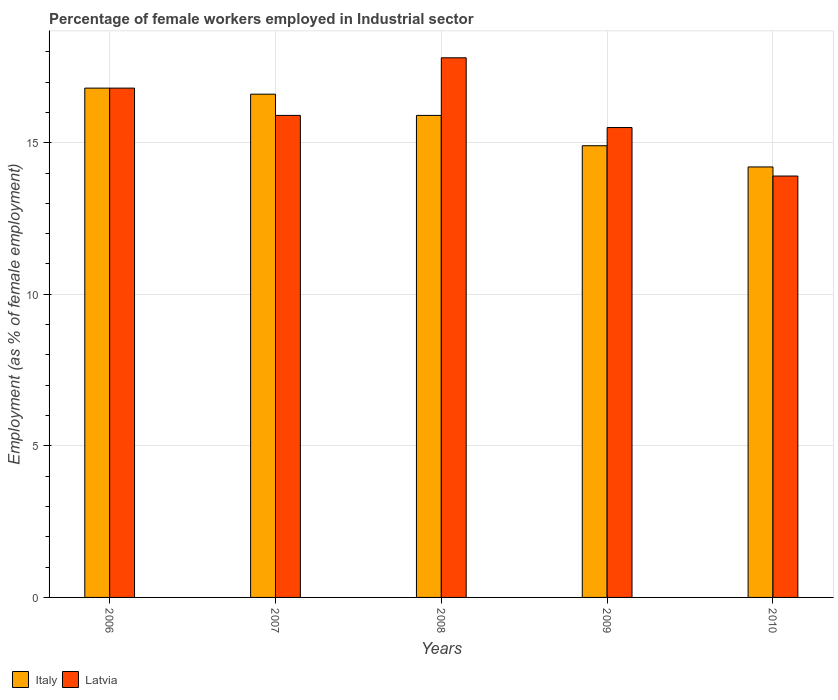How many bars are there on the 3rd tick from the left?
Offer a terse response. 2. What is the label of the 3rd group of bars from the left?
Provide a short and direct response. 2008. In how many cases, is the number of bars for a given year not equal to the number of legend labels?
Provide a short and direct response. 0. What is the percentage of females employed in Industrial sector in Latvia in 2008?
Your response must be concise. 17.8. Across all years, what is the maximum percentage of females employed in Industrial sector in Latvia?
Your response must be concise. 17.8. Across all years, what is the minimum percentage of females employed in Industrial sector in Latvia?
Your answer should be very brief. 13.9. What is the total percentage of females employed in Industrial sector in Latvia in the graph?
Your answer should be compact. 79.9. What is the difference between the percentage of females employed in Industrial sector in Italy in 2006 and that in 2009?
Your response must be concise. 1.9. What is the difference between the percentage of females employed in Industrial sector in Latvia in 2007 and the percentage of females employed in Industrial sector in Italy in 2010?
Keep it short and to the point. 1.7. What is the average percentage of females employed in Industrial sector in Latvia per year?
Offer a very short reply. 15.98. In the year 2009, what is the difference between the percentage of females employed in Industrial sector in Italy and percentage of females employed in Industrial sector in Latvia?
Your answer should be very brief. -0.6. In how many years, is the percentage of females employed in Industrial sector in Italy greater than 4 %?
Your response must be concise. 5. What is the ratio of the percentage of females employed in Industrial sector in Italy in 2006 to that in 2009?
Your response must be concise. 1.13. What is the difference between the highest and the second highest percentage of females employed in Industrial sector in Latvia?
Offer a terse response. 1. What is the difference between the highest and the lowest percentage of females employed in Industrial sector in Italy?
Give a very brief answer. 2.6. Is the sum of the percentage of females employed in Industrial sector in Latvia in 2007 and 2009 greater than the maximum percentage of females employed in Industrial sector in Italy across all years?
Your response must be concise. Yes. How many years are there in the graph?
Give a very brief answer. 5. Does the graph contain grids?
Keep it short and to the point. Yes. Where does the legend appear in the graph?
Your response must be concise. Bottom left. How many legend labels are there?
Make the answer very short. 2. What is the title of the graph?
Keep it short and to the point. Percentage of female workers employed in Industrial sector. Does "Papua New Guinea" appear as one of the legend labels in the graph?
Give a very brief answer. No. What is the label or title of the X-axis?
Offer a terse response. Years. What is the label or title of the Y-axis?
Your response must be concise. Employment (as % of female employment). What is the Employment (as % of female employment) in Italy in 2006?
Give a very brief answer. 16.8. What is the Employment (as % of female employment) in Latvia in 2006?
Give a very brief answer. 16.8. What is the Employment (as % of female employment) in Italy in 2007?
Offer a terse response. 16.6. What is the Employment (as % of female employment) in Latvia in 2007?
Offer a terse response. 15.9. What is the Employment (as % of female employment) in Italy in 2008?
Give a very brief answer. 15.9. What is the Employment (as % of female employment) of Latvia in 2008?
Make the answer very short. 17.8. What is the Employment (as % of female employment) in Italy in 2009?
Make the answer very short. 14.9. What is the Employment (as % of female employment) of Latvia in 2009?
Ensure brevity in your answer.  15.5. What is the Employment (as % of female employment) in Italy in 2010?
Offer a very short reply. 14.2. What is the Employment (as % of female employment) in Latvia in 2010?
Offer a very short reply. 13.9. Across all years, what is the maximum Employment (as % of female employment) in Italy?
Provide a succinct answer. 16.8. Across all years, what is the maximum Employment (as % of female employment) of Latvia?
Your response must be concise. 17.8. Across all years, what is the minimum Employment (as % of female employment) in Italy?
Give a very brief answer. 14.2. Across all years, what is the minimum Employment (as % of female employment) in Latvia?
Your answer should be very brief. 13.9. What is the total Employment (as % of female employment) in Italy in the graph?
Provide a succinct answer. 78.4. What is the total Employment (as % of female employment) in Latvia in the graph?
Your answer should be compact. 79.9. What is the difference between the Employment (as % of female employment) of Italy in 2006 and that in 2007?
Ensure brevity in your answer.  0.2. What is the difference between the Employment (as % of female employment) in Latvia in 2006 and that in 2009?
Offer a terse response. 1.3. What is the difference between the Employment (as % of female employment) in Latvia in 2006 and that in 2010?
Your response must be concise. 2.9. What is the difference between the Employment (as % of female employment) of Italy in 2007 and that in 2008?
Offer a terse response. 0.7. What is the difference between the Employment (as % of female employment) in Latvia in 2007 and that in 2009?
Keep it short and to the point. 0.4. What is the difference between the Employment (as % of female employment) of Italy in 2007 and that in 2010?
Your answer should be very brief. 2.4. What is the difference between the Employment (as % of female employment) of Italy in 2008 and that in 2010?
Provide a succinct answer. 1.7. What is the difference between the Employment (as % of female employment) of Latvia in 2008 and that in 2010?
Your response must be concise. 3.9. What is the difference between the Employment (as % of female employment) in Italy in 2009 and that in 2010?
Your answer should be compact. 0.7. What is the difference between the Employment (as % of female employment) of Latvia in 2009 and that in 2010?
Your response must be concise. 1.6. What is the difference between the Employment (as % of female employment) of Italy in 2006 and the Employment (as % of female employment) of Latvia in 2009?
Your answer should be compact. 1.3. What is the difference between the Employment (as % of female employment) in Italy in 2007 and the Employment (as % of female employment) in Latvia in 2008?
Offer a terse response. -1.2. What is the difference between the Employment (as % of female employment) in Italy in 2007 and the Employment (as % of female employment) in Latvia in 2009?
Ensure brevity in your answer.  1.1. What is the difference between the Employment (as % of female employment) in Italy in 2008 and the Employment (as % of female employment) in Latvia in 2009?
Provide a succinct answer. 0.4. What is the difference between the Employment (as % of female employment) of Italy in 2008 and the Employment (as % of female employment) of Latvia in 2010?
Your response must be concise. 2. What is the difference between the Employment (as % of female employment) of Italy in 2009 and the Employment (as % of female employment) of Latvia in 2010?
Offer a terse response. 1. What is the average Employment (as % of female employment) of Italy per year?
Give a very brief answer. 15.68. What is the average Employment (as % of female employment) in Latvia per year?
Offer a terse response. 15.98. In the year 2006, what is the difference between the Employment (as % of female employment) in Italy and Employment (as % of female employment) in Latvia?
Ensure brevity in your answer.  0. In the year 2009, what is the difference between the Employment (as % of female employment) of Italy and Employment (as % of female employment) of Latvia?
Make the answer very short. -0.6. What is the ratio of the Employment (as % of female employment) of Italy in 2006 to that in 2007?
Your answer should be very brief. 1.01. What is the ratio of the Employment (as % of female employment) of Latvia in 2006 to that in 2007?
Your answer should be very brief. 1.06. What is the ratio of the Employment (as % of female employment) of Italy in 2006 to that in 2008?
Keep it short and to the point. 1.06. What is the ratio of the Employment (as % of female employment) of Latvia in 2006 to that in 2008?
Your answer should be compact. 0.94. What is the ratio of the Employment (as % of female employment) of Italy in 2006 to that in 2009?
Your response must be concise. 1.13. What is the ratio of the Employment (as % of female employment) in Latvia in 2006 to that in 2009?
Ensure brevity in your answer.  1.08. What is the ratio of the Employment (as % of female employment) of Italy in 2006 to that in 2010?
Offer a terse response. 1.18. What is the ratio of the Employment (as % of female employment) in Latvia in 2006 to that in 2010?
Your answer should be compact. 1.21. What is the ratio of the Employment (as % of female employment) in Italy in 2007 to that in 2008?
Your response must be concise. 1.04. What is the ratio of the Employment (as % of female employment) of Latvia in 2007 to that in 2008?
Ensure brevity in your answer.  0.89. What is the ratio of the Employment (as % of female employment) in Italy in 2007 to that in 2009?
Offer a terse response. 1.11. What is the ratio of the Employment (as % of female employment) of Latvia in 2007 to that in 2009?
Provide a succinct answer. 1.03. What is the ratio of the Employment (as % of female employment) in Italy in 2007 to that in 2010?
Provide a succinct answer. 1.17. What is the ratio of the Employment (as % of female employment) of Latvia in 2007 to that in 2010?
Your answer should be compact. 1.14. What is the ratio of the Employment (as % of female employment) of Italy in 2008 to that in 2009?
Your answer should be very brief. 1.07. What is the ratio of the Employment (as % of female employment) in Latvia in 2008 to that in 2009?
Give a very brief answer. 1.15. What is the ratio of the Employment (as % of female employment) in Italy in 2008 to that in 2010?
Offer a terse response. 1.12. What is the ratio of the Employment (as % of female employment) of Latvia in 2008 to that in 2010?
Your response must be concise. 1.28. What is the ratio of the Employment (as % of female employment) of Italy in 2009 to that in 2010?
Make the answer very short. 1.05. What is the ratio of the Employment (as % of female employment) in Latvia in 2009 to that in 2010?
Your response must be concise. 1.12. What is the difference between the highest and the second highest Employment (as % of female employment) of Latvia?
Ensure brevity in your answer.  1. What is the difference between the highest and the lowest Employment (as % of female employment) in Italy?
Offer a terse response. 2.6. 